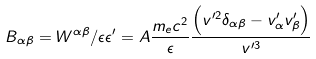<formula> <loc_0><loc_0><loc_500><loc_500>B _ { \alpha \beta } = W ^ { \alpha \beta } / \epsilon \epsilon ^ { \prime } = A \frac { m _ { e } c ^ { 2 } } { \epsilon } \frac { \left ( v ^ { \prime 2 } \delta _ { \alpha \beta } - v ^ { \prime } _ { \alpha } v ^ { \prime } _ { \beta } \right ) } { v ^ { \prime 3 } }</formula> 